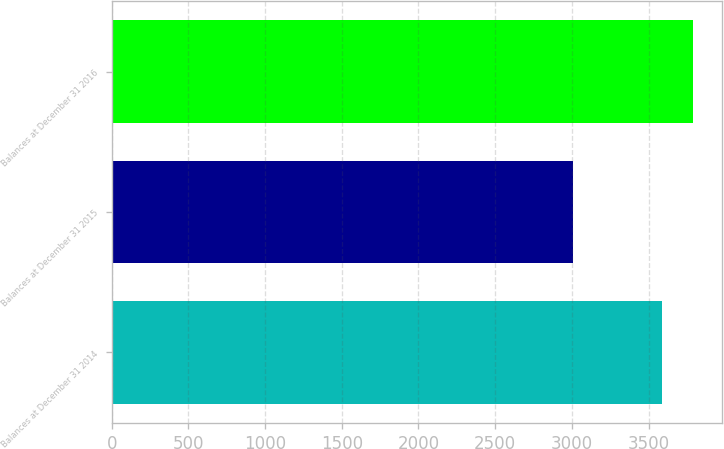Convert chart. <chart><loc_0><loc_0><loc_500><loc_500><bar_chart><fcel>Balances at December 31 2014<fcel>Balances at December 31 2015<fcel>Balances at December 31 2016<nl><fcel>3588<fcel>3007<fcel>3787<nl></chart> 